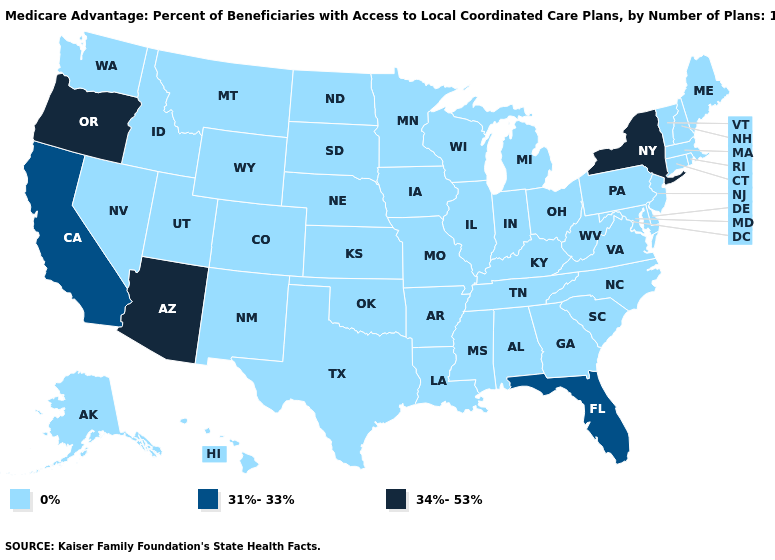Does the map have missing data?
Give a very brief answer. No. What is the highest value in the South ?
Quick response, please. 31%-33%. What is the value of North Carolina?
Quick response, please. 0%. Name the states that have a value in the range 0%?
Concise answer only. Alaska, Alabama, Arkansas, Colorado, Connecticut, Delaware, Georgia, Hawaii, Iowa, Idaho, Illinois, Indiana, Kansas, Kentucky, Louisiana, Massachusetts, Maryland, Maine, Michigan, Minnesota, Missouri, Mississippi, Montana, North Carolina, North Dakota, Nebraska, New Hampshire, New Jersey, New Mexico, Nevada, Ohio, Oklahoma, Pennsylvania, Rhode Island, South Carolina, South Dakota, Tennessee, Texas, Utah, Virginia, Vermont, Washington, Wisconsin, West Virginia, Wyoming. Name the states that have a value in the range 31%-33%?
Give a very brief answer. California, Florida. Does Indiana have a lower value than Oregon?
Short answer required. Yes. What is the value of North Carolina?
Be succinct. 0%. Name the states that have a value in the range 0%?
Concise answer only. Alaska, Alabama, Arkansas, Colorado, Connecticut, Delaware, Georgia, Hawaii, Iowa, Idaho, Illinois, Indiana, Kansas, Kentucky, Louisiana, Massachusetts, Maryland, Maine, Michigan, Minnesota, Missouri, Mississippi, Montana, North Carolina, North Dakota, Nebraska, New Hampshire, New Jersey, New Mexico, Nevada, Ohio, Oklahoma, Pennsylvania, Rhode Island, South Carolina, South Dakota, Tennessee, Texas, Utah, Virginia, Vermont, Washington, Wisconsin, West Virginia, Wyoming. What is the value of West Virginia?
Concise answer only. 0%. Does West Virginia have the lowest value in the USA?
Quick response, please. Yes. Name the states that have a value in the range 31%-33%?
Short answer required. California, Florida. What is the highest value in states that border Virginia?
Give a very brief answer. 0%. What is the value of New Hampshire?
Write a very short answer. 0%. Which states hav the highest value in the Northeast?
Answer briefly. New York. 